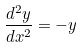Convert formula to latex. <formula><loc_0><loc_0><loc_500><loc_500>\frac { d ^ { 2 } y } { d x ^ { 2 } } = - y</formula> 